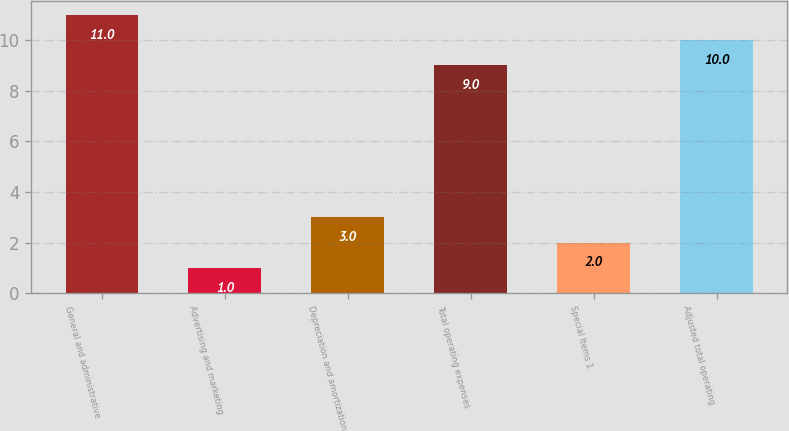<chart> <loc_0><loc_0><loc_500><loc_500><bar_chart><fcel>General and administrative<fcel>Advertising and marketing<fcel>Depreciation and amortization<fcel>Total operating expenses<fcel>Special Items 1<fcel>Adjusted total operating<nl><fcel>11<fcel>1<fcel>3<fcel>9<fcel>2<fcel>10<nl></chart> 